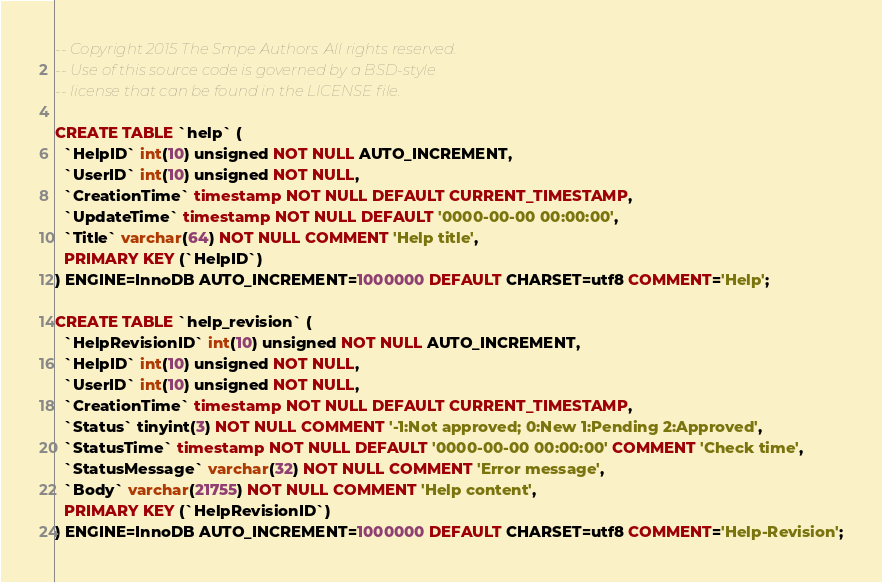<code> <loc_0><loc_0><loc_500><loc_500><_SQL_>-- Copyright 2015 The Smpe Authors. All rights reserved.
-- Use of this source code is governed by a BSD-style
-- license that can be found in the LICENSE file.

CREATE TABLE `help` (
  `HelpID` int(10) unsigned NOT NULL AUTO_INCREMENT,
  `UserID` int(10) unsigned NOT NULL,
  `CreationTime` timestamp NOT NULL DEFAULT CURRENT_TIMESTAMP,
  `UpdateTime` timestamp NOT NULL DEFAULT '0000-00-00 00:00:00',
  `Title` varchar(64) NOT NULL COMMENT 'Help title',
  PRIMARY KEY (`HelpID`)
) ENGINE=InnoDB AUTO_INCREMENT=1000000 DEFAULT CHARSET=utf8 COMMENT='Help';

CREATE TABLE `help_revision` (
  `HelpRevisionID` int(10) unsigned NOT NULL AUTO_INCREMENT,
  `HelpID` int(10) unsigned NOT NULL,
  `UserID` int(10) unsigned NOT NULL,
  `CreationTime` timestamp NOT NULL DEFAULT CURRENT_TIMESTAMP,
  `Status` tinyint(3) NOT NULL COMMENT '-1:Not approved; 0:New 1:Pending 2:Approved',
  `StatusTime` timestamp NOT NULL DEFAULT '0000-00-00 00:00:00' COMMENT 'Check time',
  `StatusMessage` varchar(32) NOT NULL COMMENT 'Error message',
  `Body` varchar(21755) NOT NULL COMMENT 'Help content',
  PRIMARY KEY (`HelpRevisionID`)
) ENGINE=InnoDB AUTO_INCREMENT=1000000 DEFAULT CHARSET=utf8 COMMENT='Help-Revision';

</code> 